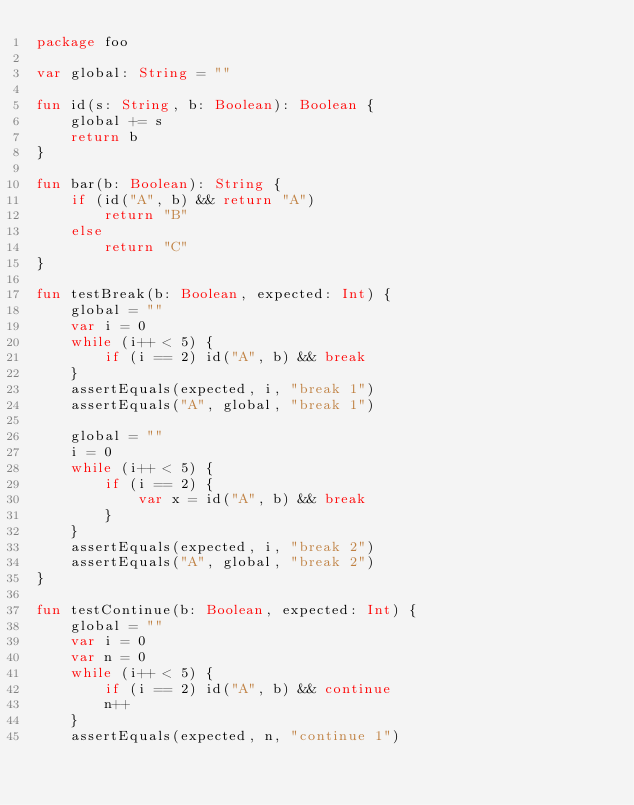<code> <loc_0><loc_0><loc_500><loc_500><_Kotlin_>package foo

var global: String = ""

fun id(s: String, b: Boolean): Boolean {
    global += s
    return b
}

fun bar(b: Boolean): String {
    if (id("A", b) && return "A")
        return "B"
    else
        return "C"
}

fun testBreak(b: Boolean, expected: Int) {
    global = ""
    var i = 0
    while (i++ < 5) {
        if (i == 2) id("A", b) && break
    }
    assertEquals(expected, i, "break 1")
    assertEquals("A", global, "break 1")

    global = ""
    i = 0
    while (i++ < 5) {
        if (i == 2) {
            var x = id("A", b) && break
        }
    }
    assertEquals(expected, i, "break 2")
    assertEquals("A", global, "break 2")
}

fun testContinue(b: Boolean, expected: Int) {
    global = ""
    var i = 0
    var n = 0
    while (i++ < 5) {
        if (i == 2) id("A", b) && continue
        n++
    }
    assertEquals(expected, n, "continue 1")</code> 